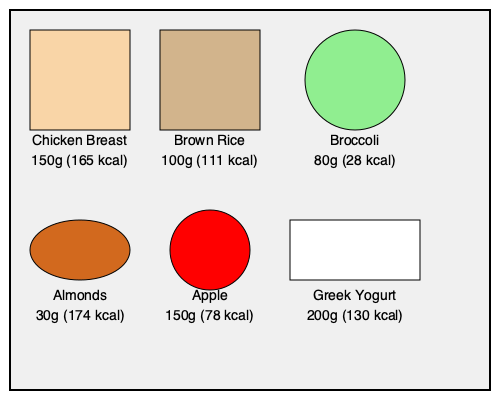Based on the visual representation of various food portions and their calorie content, calculate the total calorie intake for a meal consisting of half the chicken breast, all of the brown rice, the full portion of broccoli, and one-third of the almonds. Round your answer to the nearest whole number. To calculate the total calorie intake for the specified meal, we'll follow these steps:

1. Chicken breast (half portion):
   * Full portion: 150g = 165 kcal
   * Half portion: $165 \div 2 = 82.5$ kcal

2. Brown rice (full portion):
   * 100g = 111 kcal

3. Broccoli (full portion):
   * 80g = 28 kcal

4. Almonds (one-third portion):
   * Full portion: 30g = 174 kcal
   * One-third portion: $174 \div 3 = 58$ kcal

5. Sum up the calories:
   $$ \text{Total calories} = 82.5 + 111 + 28 + 58 = 279.5 \text{ kcal} $$

6. Round to the nearest whole number:
   $$ 279.5 \text{ kcal} \approx 280 \text{ kcal} $$

Therefore, the total calorie intake for the specified meal, rounded to the nearest whole number, is 280 kcal.
Answer: 280 kcal 